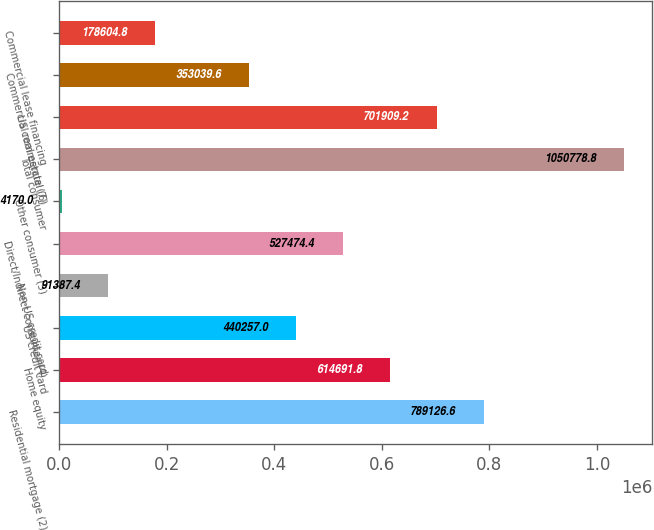Convert chart to OTSL. <chart><loc_0><loc_0><loc_500><loc_500><bar_chart><fcel>Residential mortgage (2)<fcel>Home equity<fcel>US credit card<fcel>Non-US credit card<fcel>Direct/Indirect consumer (4)<fcel>Other consumer (5)<fcel>Total consumer<fcel>US commercial (6)<fcel>Commercial real estate (7)<fcel>Commercial lease financing<nl><fcel>789127<fcel>614692<fcel>440257<fcel>91387.4<fcel>527474<fcel>4170<fcel>1.05078e+06<fcel>701909<fcel>353040<fcel>178605<nl></chart> 